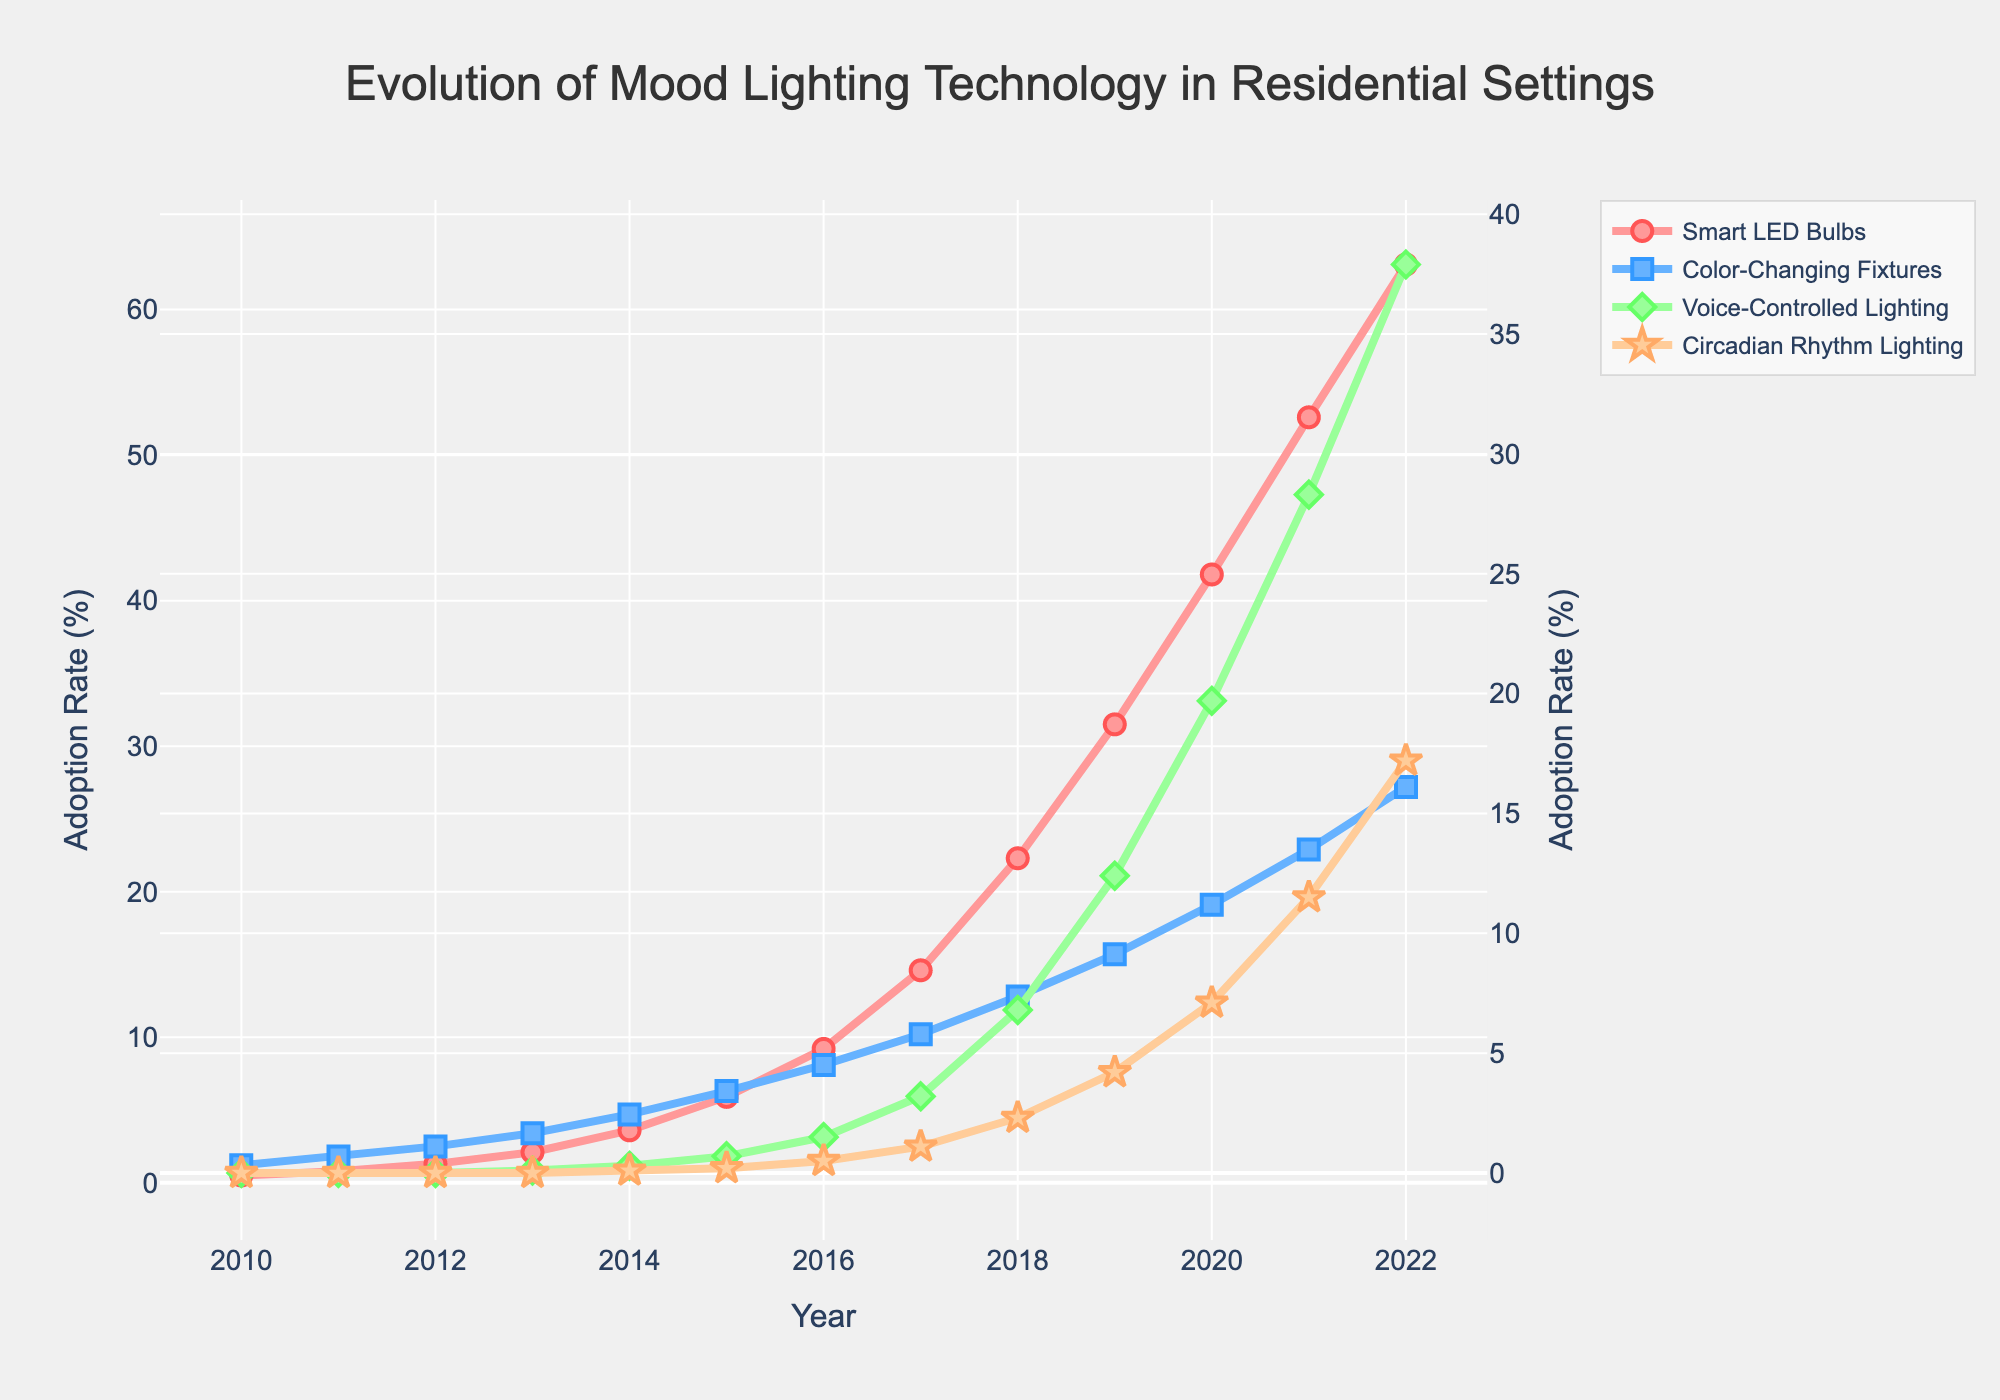What's the trend in smart LED bulbs adoption between 2010 and 2022? To determine the trend, observe the line for Smart LED Bulbs on the graph from 2010 to 2022. It starts at 0.5% in 2010 and rises to 63.1% in 2022, indicating a general upward trend.
Answer: Upward trend When did voice-controlled lighting start to experience significant adoption rates? Look at the trajectory of the Voice-Controlled Lighting line. It remains at 0% until 2013, then begins to increase more notably from 2016 onwards, going from 1.5% to 37.9% by 2022.
Answer: 2016 By how much did the adoption rate of color-changing fixtures increase from 2010 to 2015? Find the adoption rates for Color-Changing Fixtures in 2010 and 2015, which are 1.2% and 6.3%, respectively. The increase is 6.3% - 1.2% = 5.1%.
Answer: 5.1% Which type of lighting has the steepest growth from 2010 to 2022? Compare the slopes (steepness) of the lines for each type of lighting. Smart LED Bulbs grow from 0.5% to 63.1%, Voice-Controlled Lighting from 0% to 37.9%, Color-Changing Fixtures from 1.2% to 27.2%, and Circadian Rhythm Lighting from 0% to 17.2%. Smart LED Bulbs have the steepest increase.
Answer: Smart LED Bulbs In what year did circadian rhythm lighting reach a 10% adoption rate? Follow the Circadian Rhythm Lighting line until it intersects with the 10% mark on the y-axis. This occurs around 2021.
Answer: 2021 Compare the adoption rate of smart LED bulbs and color-changing fixtures in 2020. Which was higher and by how much? Check the adoption rates in 2020: Smart LED Bulbs at 41.8% and Color-Changing Fixtures at 19.1%. Subtract to find the difference: 41.8% - 19.1% = 22.7%.
Answer: Smart LED Bulbs by 22.7% How does the adoption of smart LED bulbs in 2017 compare to voice-controlled lighting in the same year? Find the adoption rates for both in 2017: Smart LED Bulbs at 14.6% and Voice-Controlled Lighting at 3.2%. Therefore, Smart LED Bulbs had a higher adoption rate.
Answer: Smart LED Bulbs higher What's the average adoption rate of circadian rhythm lighting from 2018 to 2022? Average the rates from 2018 (2.3%), 2019 (4.2%), 2020 (7.1%), 2021 (11.5%), and 2022 (17.2%). Calculate (2.3% + 4.2% + 7.1% + 11.5% + 17.2%) / 5 = 8.46%.
Answer: 8.46% How does the overlap of the heart-shaped watermark affect the visibility of the data points? The heart-shaped watermark is centrally placed with partial transparency, covering part of the data points without significantly obstructing the data lines, ensuring that the overall data is still readable.
Answer: Partial transparency, minimally obstructive 